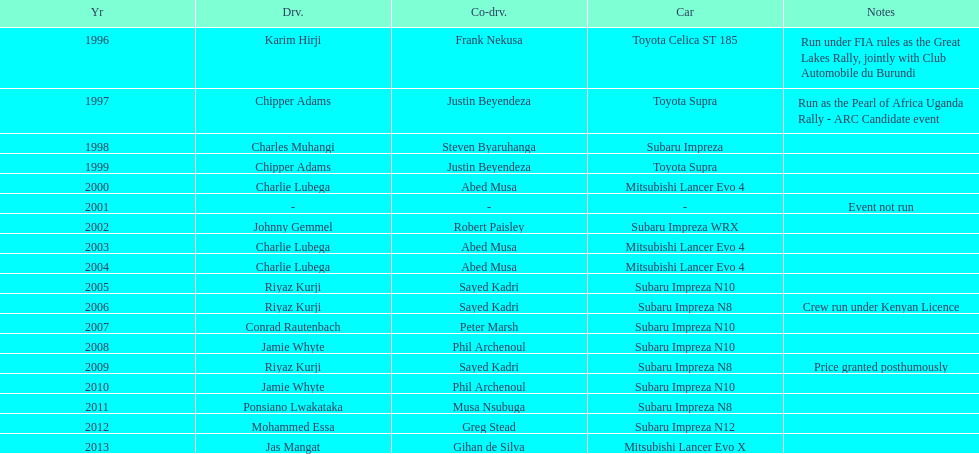Which was the only year that the event was not run? 2001. 